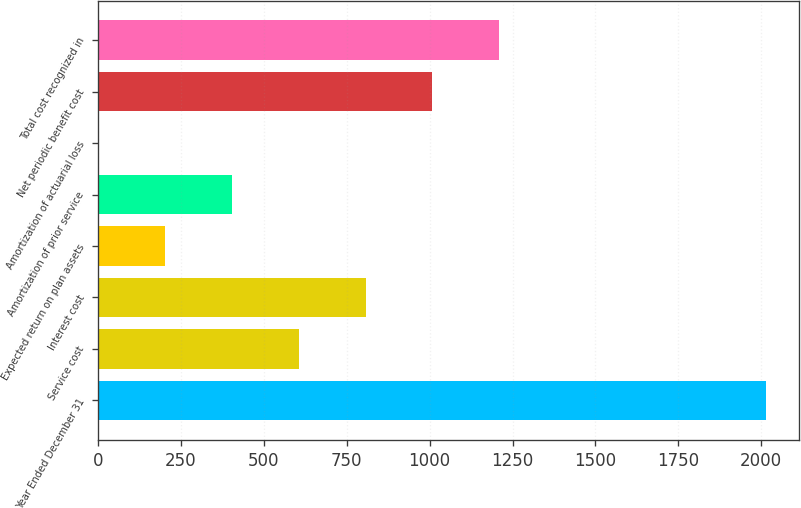Convert chart to OTSL. <chart><loc_0><loc_0><loc_500><loc_500><bar_chart><fcel>Year Ended December 31<fcel>Service cost<fcel>Interest cost<fcel>Expected return on plan assets<fcel>Amortization of prior service<fcel>Amortization of actuarial loss<fcel>Net periodic benefit cost<fcel>Total cost recognized in<nl><fcel>2014<fcel>605.6<fcel>806.8<fcel>203.2<fcel>404.4<fcel>2<fcel>1008<fcel>1209.2<nl></chart> 